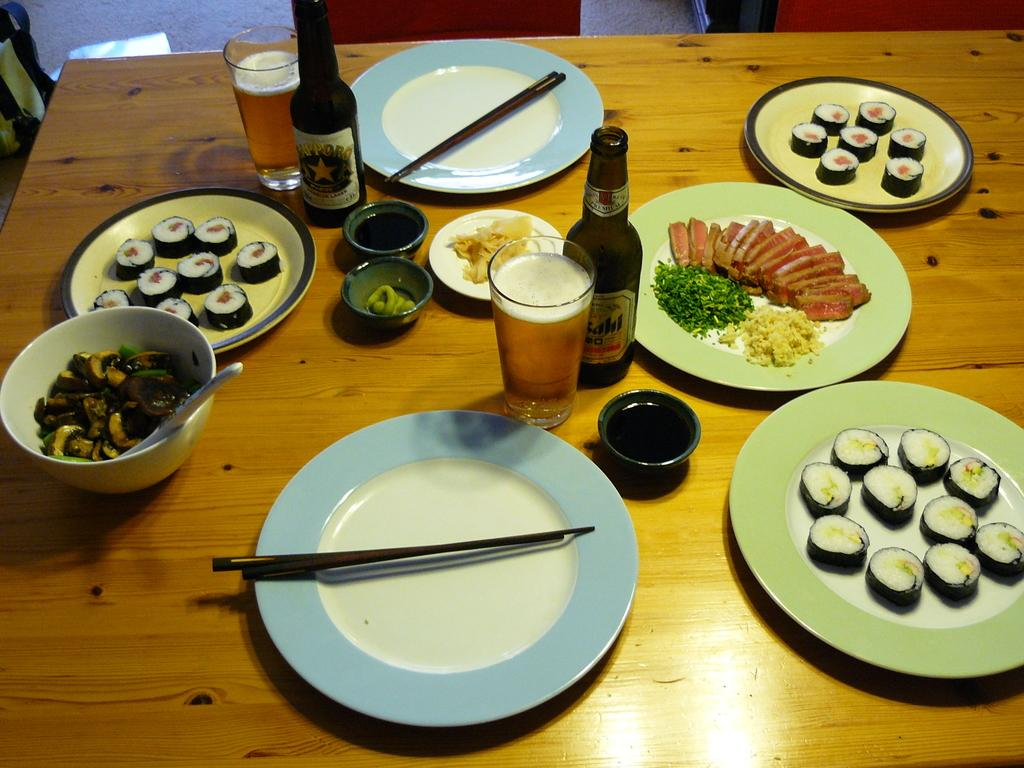What is the main object in the center of the image? There is a table in the center of the image. What can be found on the table? There are food items, a plate, a glass, and beer bottles on the table. How many chairs are around the table? There are chairs around the table. What type of circle can be seen on the table in the image? There is no circle present on the table in the image. Can you tell me how many feet are visible in the image? There are no feet visible in the image. 